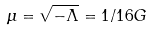Convert formula to latex. <formula><loc_0><loc_0><loc_500><loc_500>\mu = \sqrt { - \Lambda } = 1 / 1 6 G</formula> 